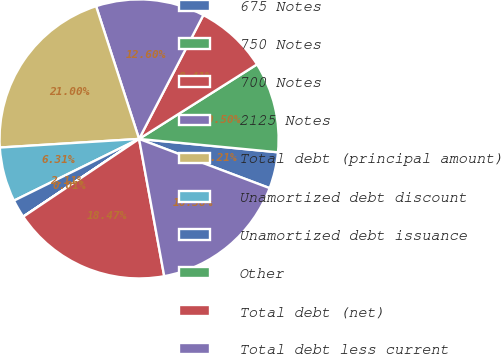Convert chart. <chart><loc_0><loc_0><loc_500><loc_500><pie_chart><fcel>675 Notes<fcel>750 Notes<fcel>700 Notes<fcel>2125 Notes<fcel>Total debt (principal amount)<fcel>Unamortized debt discount<fcel>Unamortized debt issuance<fcel>Other<fcel>Total debt (net)<fcel>Total debt less current<nl><fcel>4.21%<fcel>10.5%<fcel>8.41%<fcel>12.6%<fcel>21.0%<fcel>6.31%<fcel>2.11%<fcel>0.01%<fcel>18.47%<fcel>16.38%<nl></chart> 